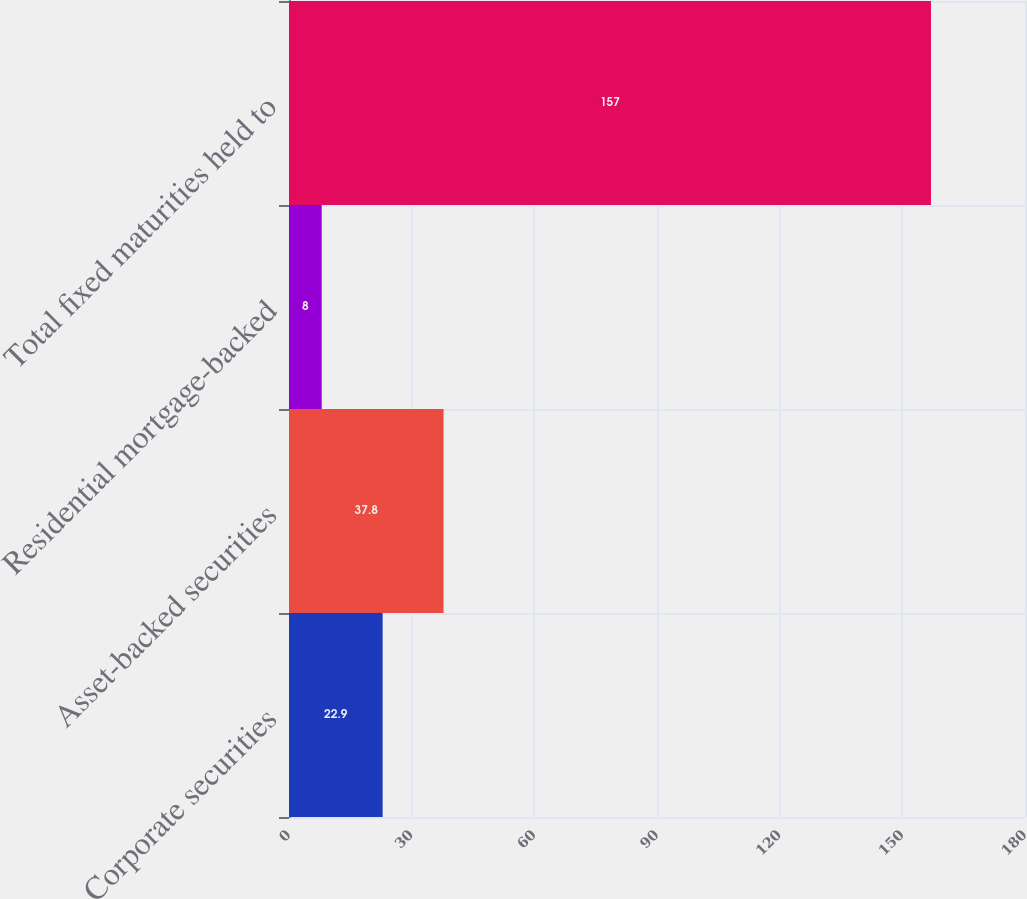<chart> <loc_0><loc_0><loc_500><loc_500><bar_chart><fcel>Corporate securities<fcel>Asset-backed securities<fcel>Residential mortgage-backed<fcel>Total fixed maturities held to<nl><fcel>22.9<fcel>37.8<fcel>8<fcel>157<nl></chart> 